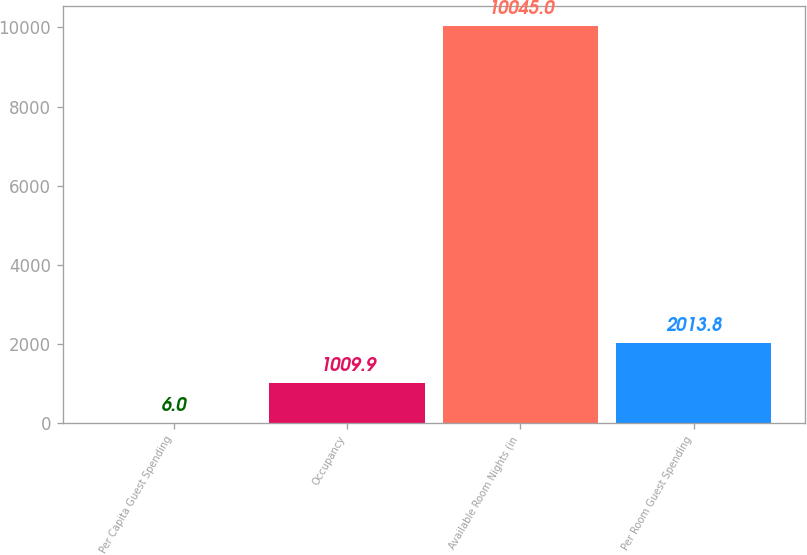<chart> <loc_0><loc_0><loc_500><loc_500><bar_chart><fcel>Per Capita Guest Spending<fcel>Occupancy<fcel>Available Room Nights (in<fcel>Per Room Guest Spending<nl><fcel>6<fcel>1009.9<fcel>10045<fcel>2013.8<nl></chart> 